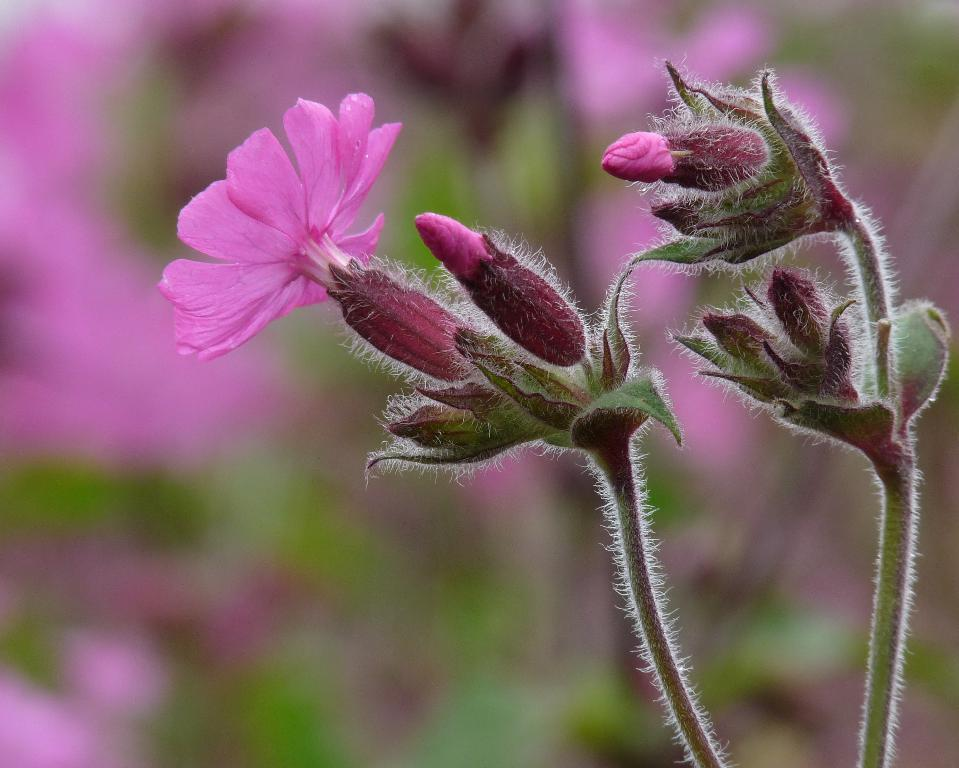What color are the flowers on the plant in the image? The flowers on the plant are pink. What stage of growth are some of the flowers in? There are buds on the plant, indicating that some flowers are not yet fully bloomed. Can you describe the background of the image? The background of the image appears blurry. How many balls are visible in the image? There are no balls present in the image. What type of design can be seen on the leaves of the plant? The provided facts do not mention any specific design on the leaves of the plant. 